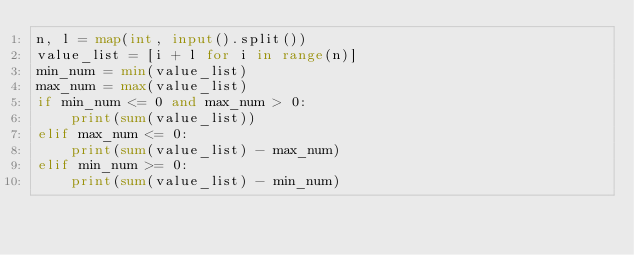Convert code to text. <code><loc_0><loc_0><loc_500><loc_500><_Python_>n, l = map(int, input().split())
value_list = [i + l for i in range(n)]
min_num = min(value_list)
max_num = max(value_list)
if min_num <= 0 and max_num > 0:
    print(sum(value_list))
elif max_num <= 0:
    print(sum(value_list) - max_num)
elif min_num >= 0:
    print(sum(value_list) - min_num)</code> 